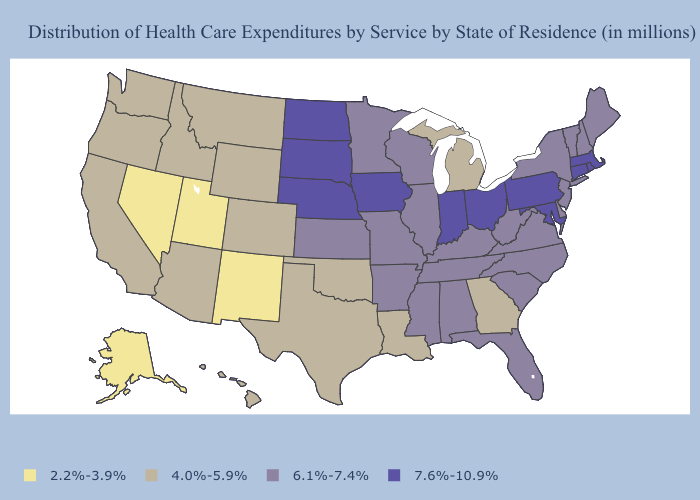Name the states that have a value in the range 7.6%-10.9%?
Answer briefly. Connecticut, Indiana, Iowa, Maryland, Massachusetts, Nebraska, North Dakota, Ohio, Pennsylvania, Rhode Island, South Dakota. Among the states that border New Mexico , which have the highest value?
Write a very short answer. Arizona, Colorado, Oklahoma, Texas. What is the value of Georgia?
Quick response, please. 4.0%-5.9%. Which states have the highest value in the USA?
Quick response, please. Connecticut, Indiana, Iowa, Maryland, Massachusetts, Nebraska, North Dakota, Ohio, Pennsylvania, Rhode Island, South Dakota. Does Illinois have a lower value than Indiana?
Be succinct. Yes. Among the states that border Massachusetts , which have the highest value?
Write a very short answer. Connecticut, Rhode Island. What is the value of Wyoming?
Short answer required. 4.0%-5.9%. What is the highest value in the Northeast ?
Concise answer only. 7.6%-10.9%. Does Texas have a lower value than Georgia?
Short answer required. No. Name the states that have a value in the range 6.1%-7.4%?
Be succinct. Alabama, Arkansas, Delaware, Florida, Illinois, Kansas, Kentucky, Maine, Minnesota, Mississippi, Missouri, New Hampshire, New Jersey, New York, North Carolina, South Carolina, Tennessee, Vermont, Virginia, West Virginia, Wisconsin. Does the first symbol in the legend represent the smallest category?
Write a very short answer. Yes. What is the value of Delaware?
Be succinct. 6.1%-7.4%. What is the value of Tennessee?
Be succinct. 6.1%-7.4%. What is the value of Maine?
Concise answer only. 6.1%-7.4%. Name the states that have a value in the range 7.6%-10.9%?
Quick response, please. Connecticut, Indiana, Iowa, Maryland, Massachusetts, Nebraska, North Dakota, Ohio, Pennsylvania, Rhode Island, South Dakota. 